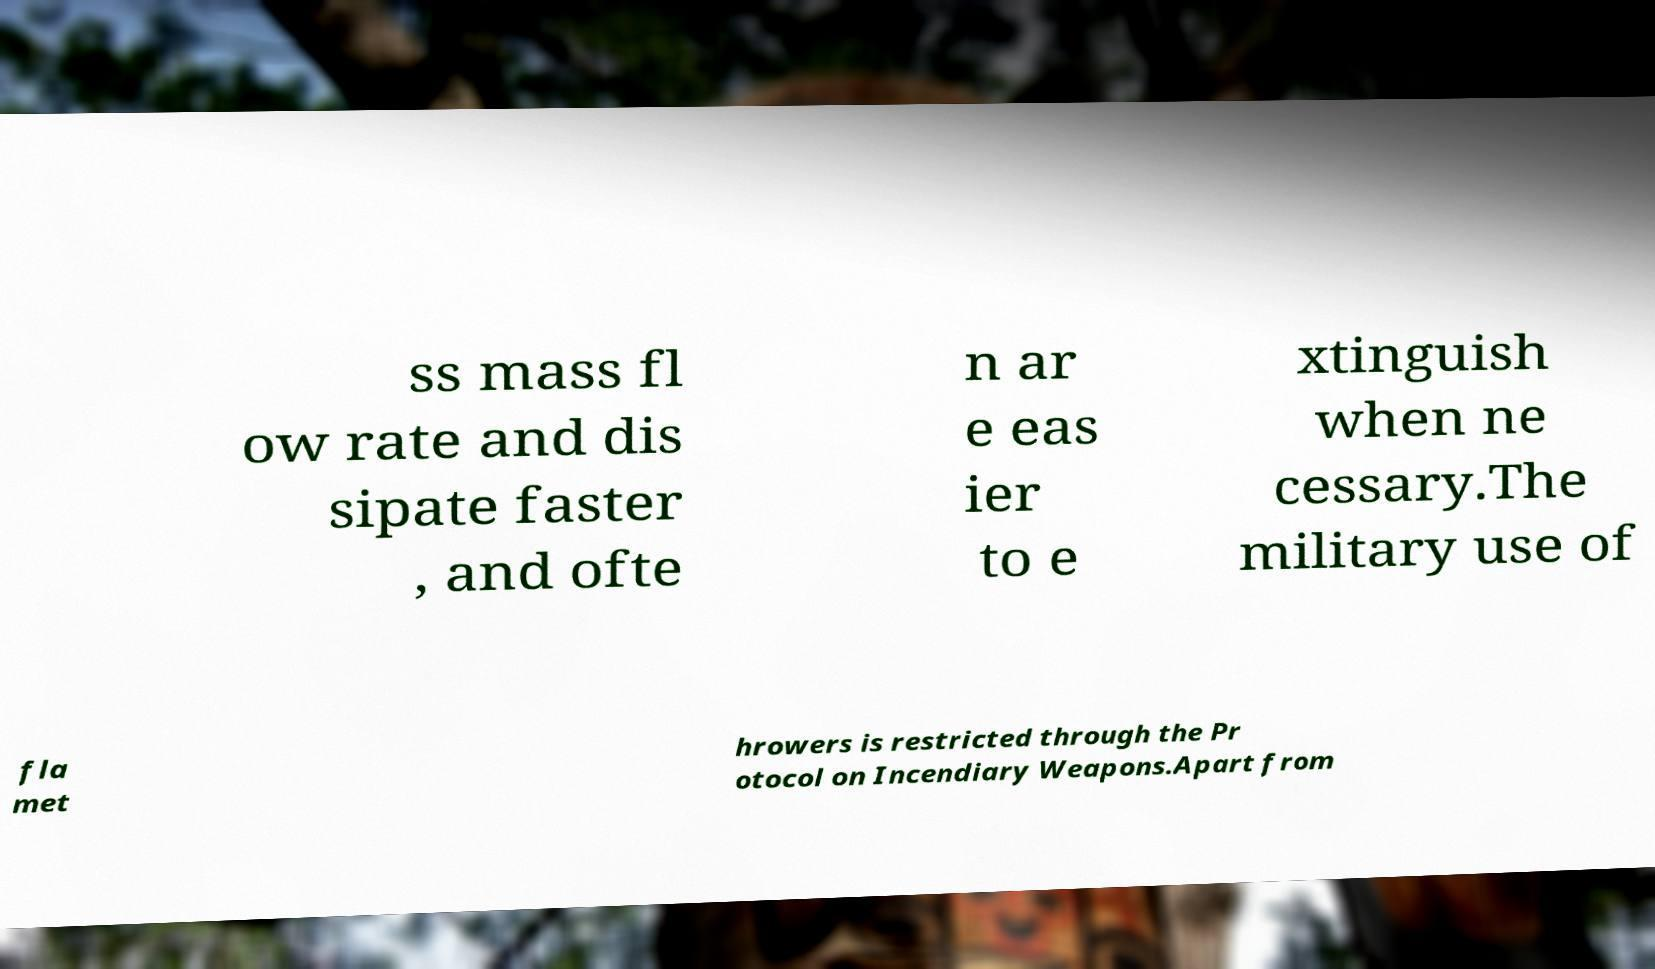Can you accurately transcribe the text from the provided image for me? ss mass fl ow rate and dis sipate faster , and ofte n ar e eas ier to e xtinguish when ne cessary.The military use of fla met hrowers is restricted through the Pr otocol on Incendiary Weapons.Apart from 